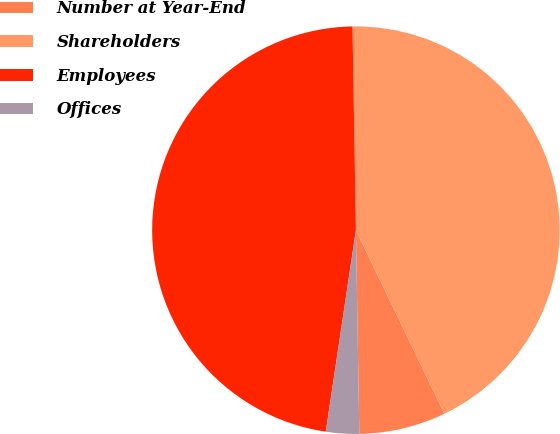Convert chart to OTSL. <chart><loc_0><loc_0><loc_500><loc_500><pie_chart><fcel>Number at Year-End<fcel>Shareholders<fcel>Employees<fcel>Offices<nl><fcel>6.88%<fcel>43.12%<fcel>47.37%<fcel>2.63%<nl></chart> 